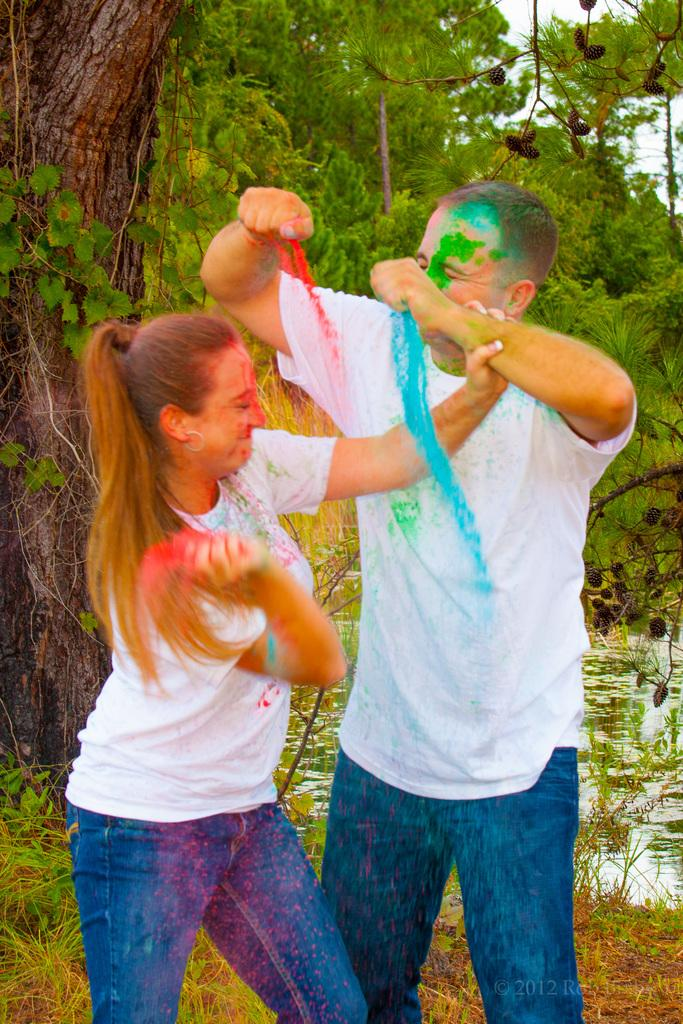How many people are in the image? There are two people in the image, a man and a woman. What are the man and the woman holding in their hands? They are holding colors in their hands. What is the natural environment visible in the background of the image? There are trees, water, and grass visible in the background of the image. What type of yarn is the woman using to knit a sweater in the image? There is no yarn or sweater present in the image; the woman is holding colors in her hands. How many people are walking in the image? The provided facts do not mention anyone walking in the image. 